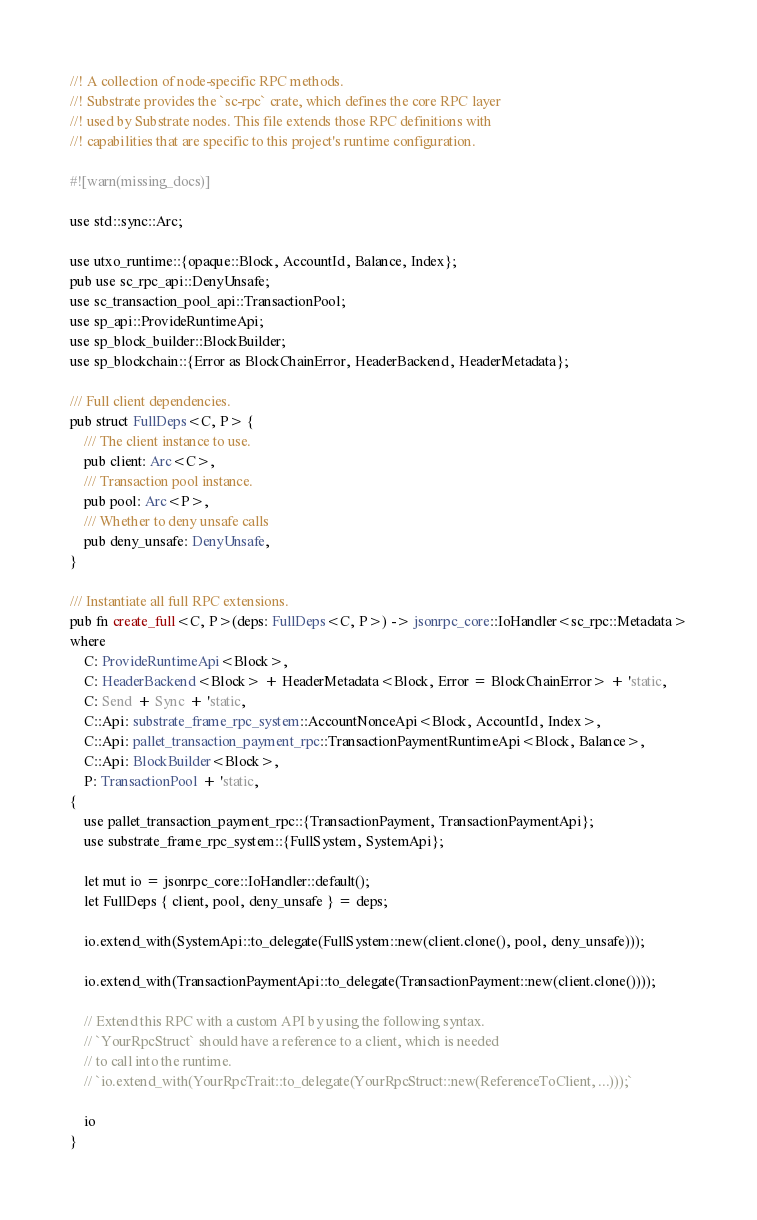<code> <loc_0><loc_0><loc_500><loc_500><_Rust_>//! A collection of node-specific RPC methods.
//! Substrate provides the `sc-rpc` crate, which defines the core RPC layer
//! used by Substrate nodes. This file extends those RPC definitions with
//! capabilities that are specific to this project's runtime configuration.

#![warn(missing_docs)]

use std::sync::Arc;

use utxo_runtime::{opaque::Block, AccountId, Balance, Index};
pub use sc_rpc_api::DenyUnsafe;
use sc_transaction_pool_api::TransactionPool;
use sp_api::ProvideRuntimeApi;
use sp_block_builder::BlockBuilder;
use sp_blockchain::{Error as BlockChainError, HeaderBackend, HeaderMetadata};

/// Full client dependencies.
pub struct FullDeps<C, P> {
	/// The client instance to use.
	pub client: Arc<C>,
	/// Transaction pool instance.
	pub pool: Arc<P>,
	/// Whether to deny unsafe calls
	pub deny_unsafe: DenyUnsafe,
}

/// Instantiate all full RPC extensions.
pub fn create_full<C, P>(deps: FullDeps<C, P>) -> jsonrpc_core::IoHandler<sc_rpc::Metadata>
where
	C: ProvideRuntimeApi<Block>,
	C: HeaderBackend<Block> + HeaderMetadata<Block, Error = BlockChainError> + 'static,
	C: Send + Sync + 'static,
	C::Api: substrate_frame_rpc_system::AccountNonceApi<Block, AccountId, Index>,
	C::Api: pallet_transaction_payment_rpc::TransactionPaymentRuntimeApi<Block, Balance>,
	C::Api: BlockBuilder<Block>,
	P: TransactionPool + 'static,
{
	use pallet_transaction_payment_rpc::{TransactionPayment, TransactionPaymentApi};
	use substrate_frame_rpc_system::{FullSystem, SystemApi};

	let mut io = jsonrpc_core::IoHandler::default();
	let FullDeps { client, pool, deny_unsafe } = deps;

	io.extend_with(SystemApi::to_delegate(FullSystem::new(client.clone(), pool, deny_unsafe)));

	io.extend_with(TransactionPaymentApi::to_delegate(TransactionPayment::new(client.clone())));

	// Extend this RPC with a custom API by using the following syntax.
	// `YourRpcStruct` should have a reference to a client, which is needed
	// to call into the runtime.
	// `io.extend_with(YourRpcTrait::to_delegate(YourRpcStruct::new(ReferenceToClient, ...)));`

	io
}
</code> 